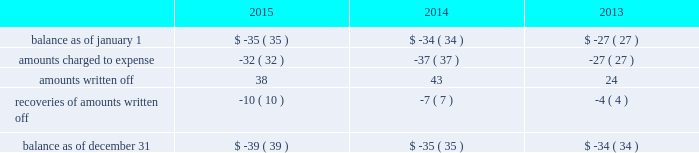Note 4 : property , plant and equipment the table summarizes the major classes of property , plant and equipment by category as of december 31 : 2015 2014 range of remaining useful weighted average useful life utility plant : land and other non-depreciable assets .
$ 141 $ 137 sources of supply .
705 681 12 to 127 years 51 years treatment and pumping facilities .
3070 2969 3 to 101 years 39 years transmission and distribution facilities .
8516 7963 9 to 156 years 83 years services , meters and fire hydrants .
3250 3062 8 to 93 years 35 years general structures and equipment .
1227 1096 1 to 154 years 39 years waste treatment , pumping and disposal .
313 281 2 to 115 years 46 years waste collection .
473 399 5 to 109 years 56 years construction work in progress .
404 303 total utility plant .
18099 16891 nonutility property .
405 378 3 to 50 years 6 years total property , plant and equipment .
$ 18504 $ 17269 property , plant and equipment depreciation expense amounted to $ 405 , $ 392 , and $ 374 for the years ended december 31 , 2015 , 2014 and 2013 , respectively and was included in depreciation and amortization expense in the accompanying consolidated statements of operations .
The provision for depreciation expressed as a percentage of the aggregate average depreciable asset balances was 3.13% ( 3.13 % ) for the year ended december 31 , 2015 and 3.20% ( 3.20 % ) for years december 31 , 2014 and 2013 .
Note 5 : allowance for uncollectible accounts the table summarizes the changes in the company 2019s allowances for uncollectible accounts for the years ended december 31: .

What was the change in accumulated depreciation from depreciation expenses from 2013 to december 31 , 2015? 
Rationale: the amount of accumulated depreciation from the years 2015-2013 was the the sum of the depreciation expense for each year .
Computations: ((405 + 392) + 374)
Answer: 1171.0. 